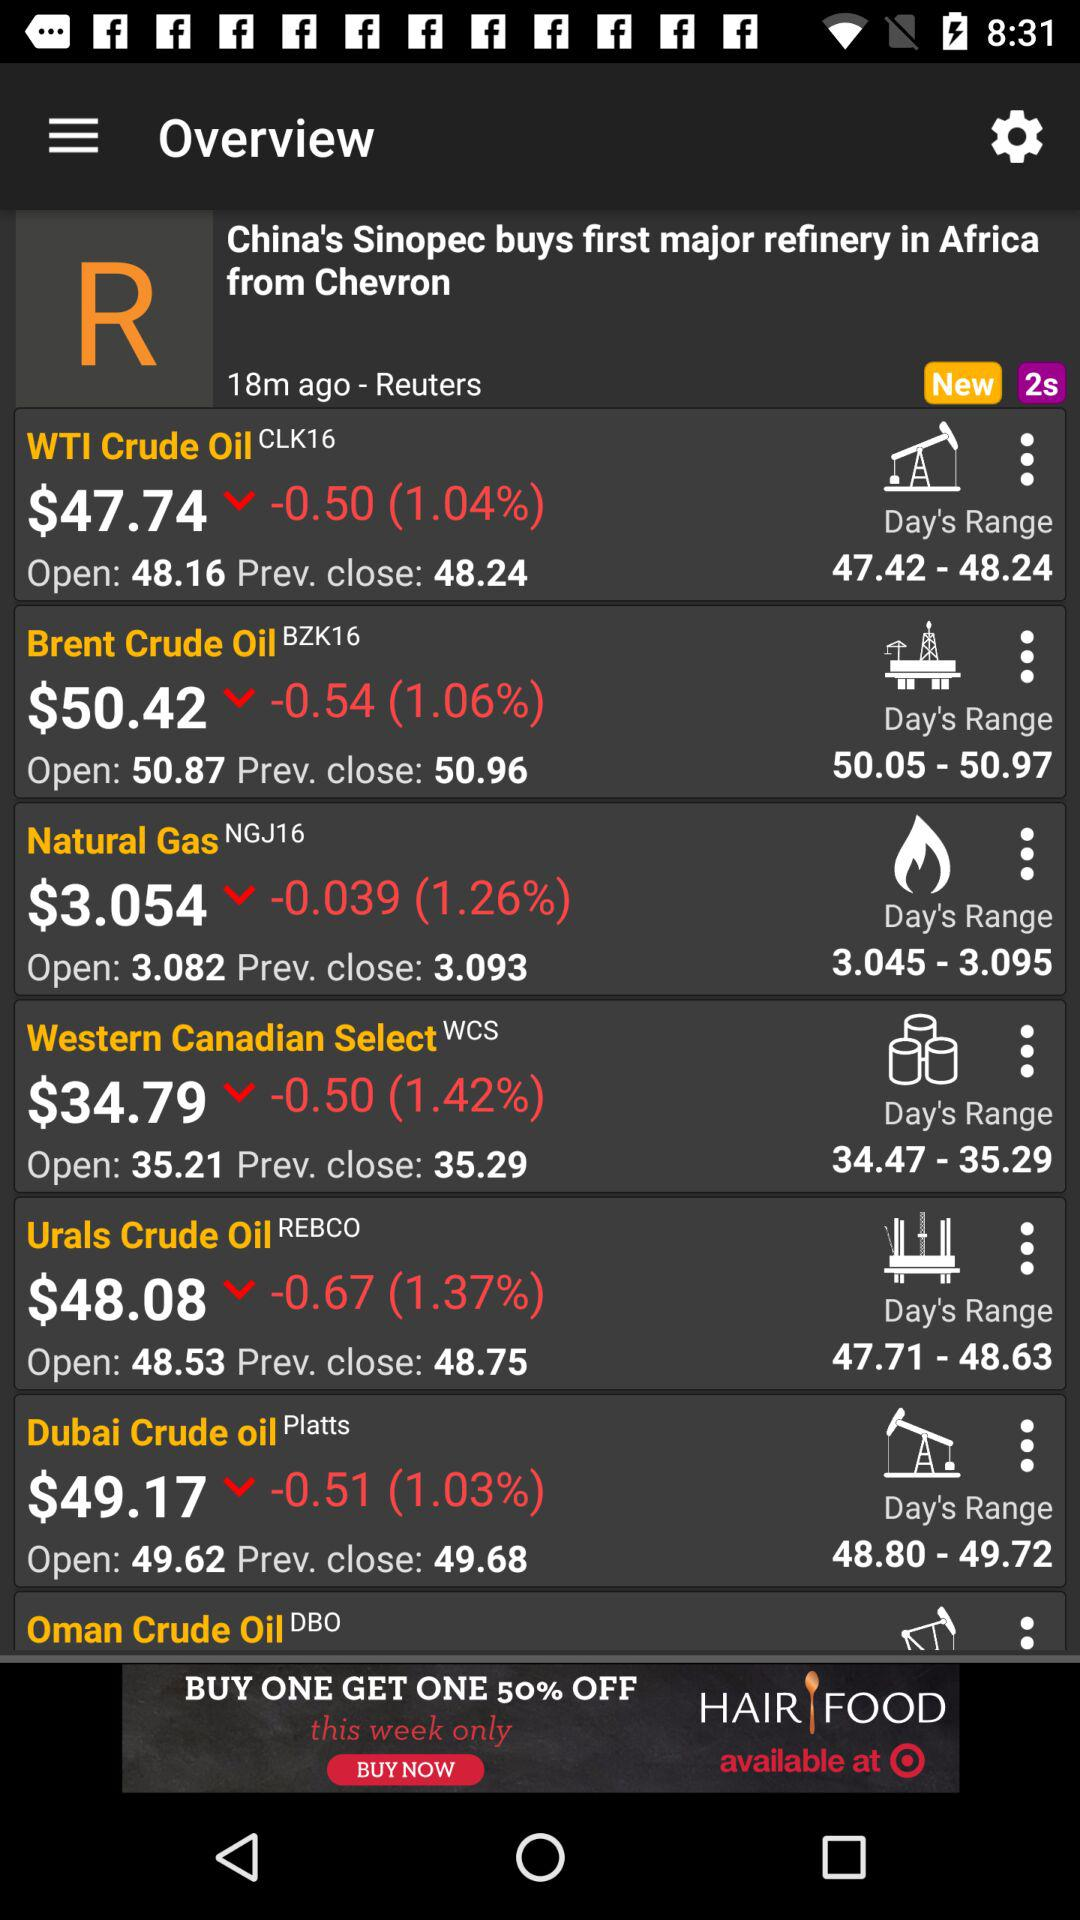What is the opening value of "Dubai Crude oil"? The opening value of "Dubai Crude oil" is 49.62. 